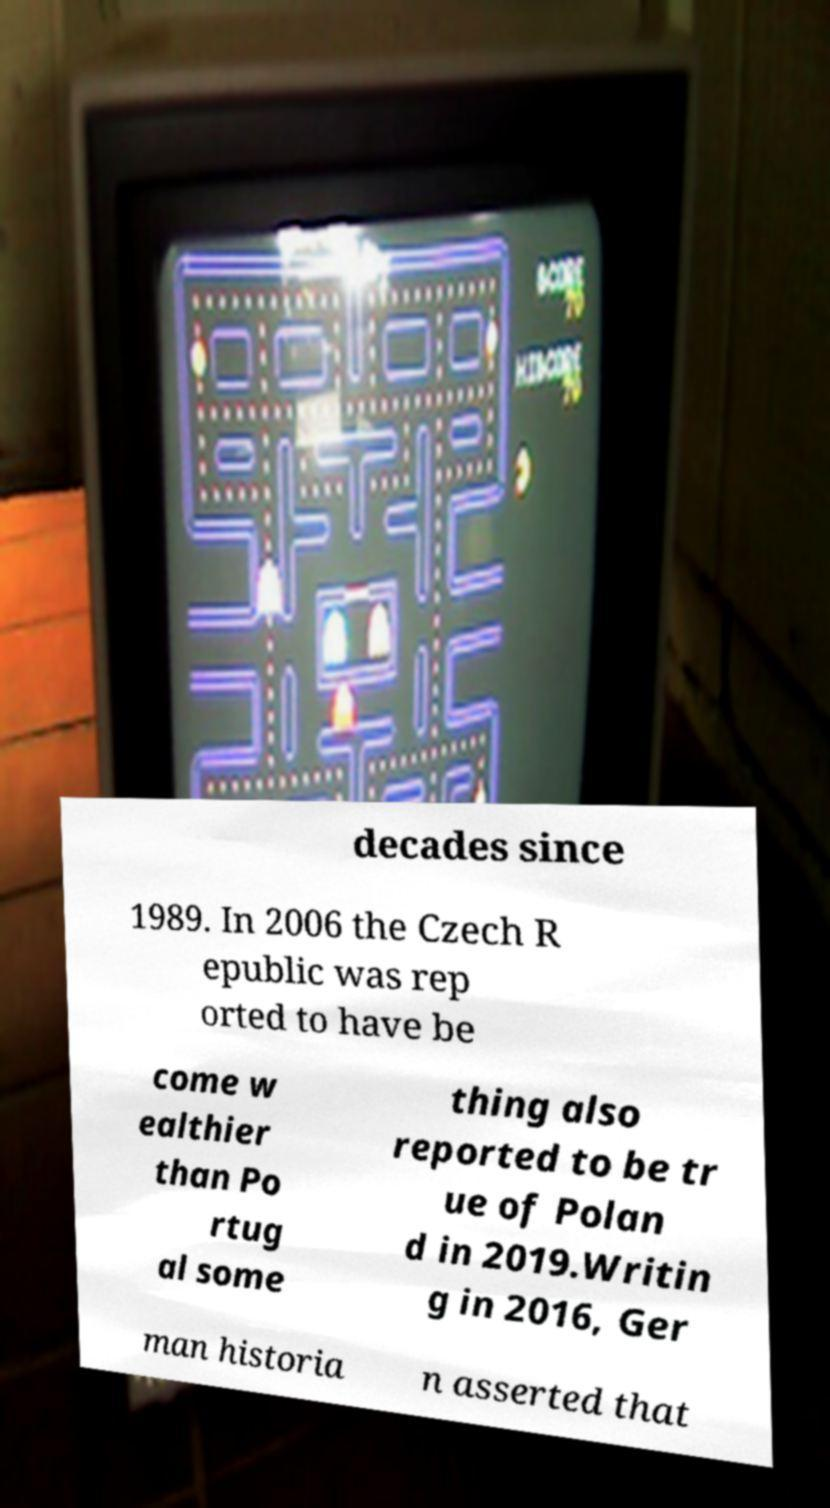What messages or text are displayed in this image? I need them in a readable, typed format. decades since 1989. In 2006 the Czech R epublic was rep orted to have be come w ealthier than Po rtug al some thing also reported to be tr ue of Polan d in 2019.Writin g in 2016, Ger man historia n asserted that 